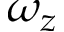Convert formula to latex. <formula><loc_0><loc_0><loc_500><loc_500>\omega _ { z }</formula> 